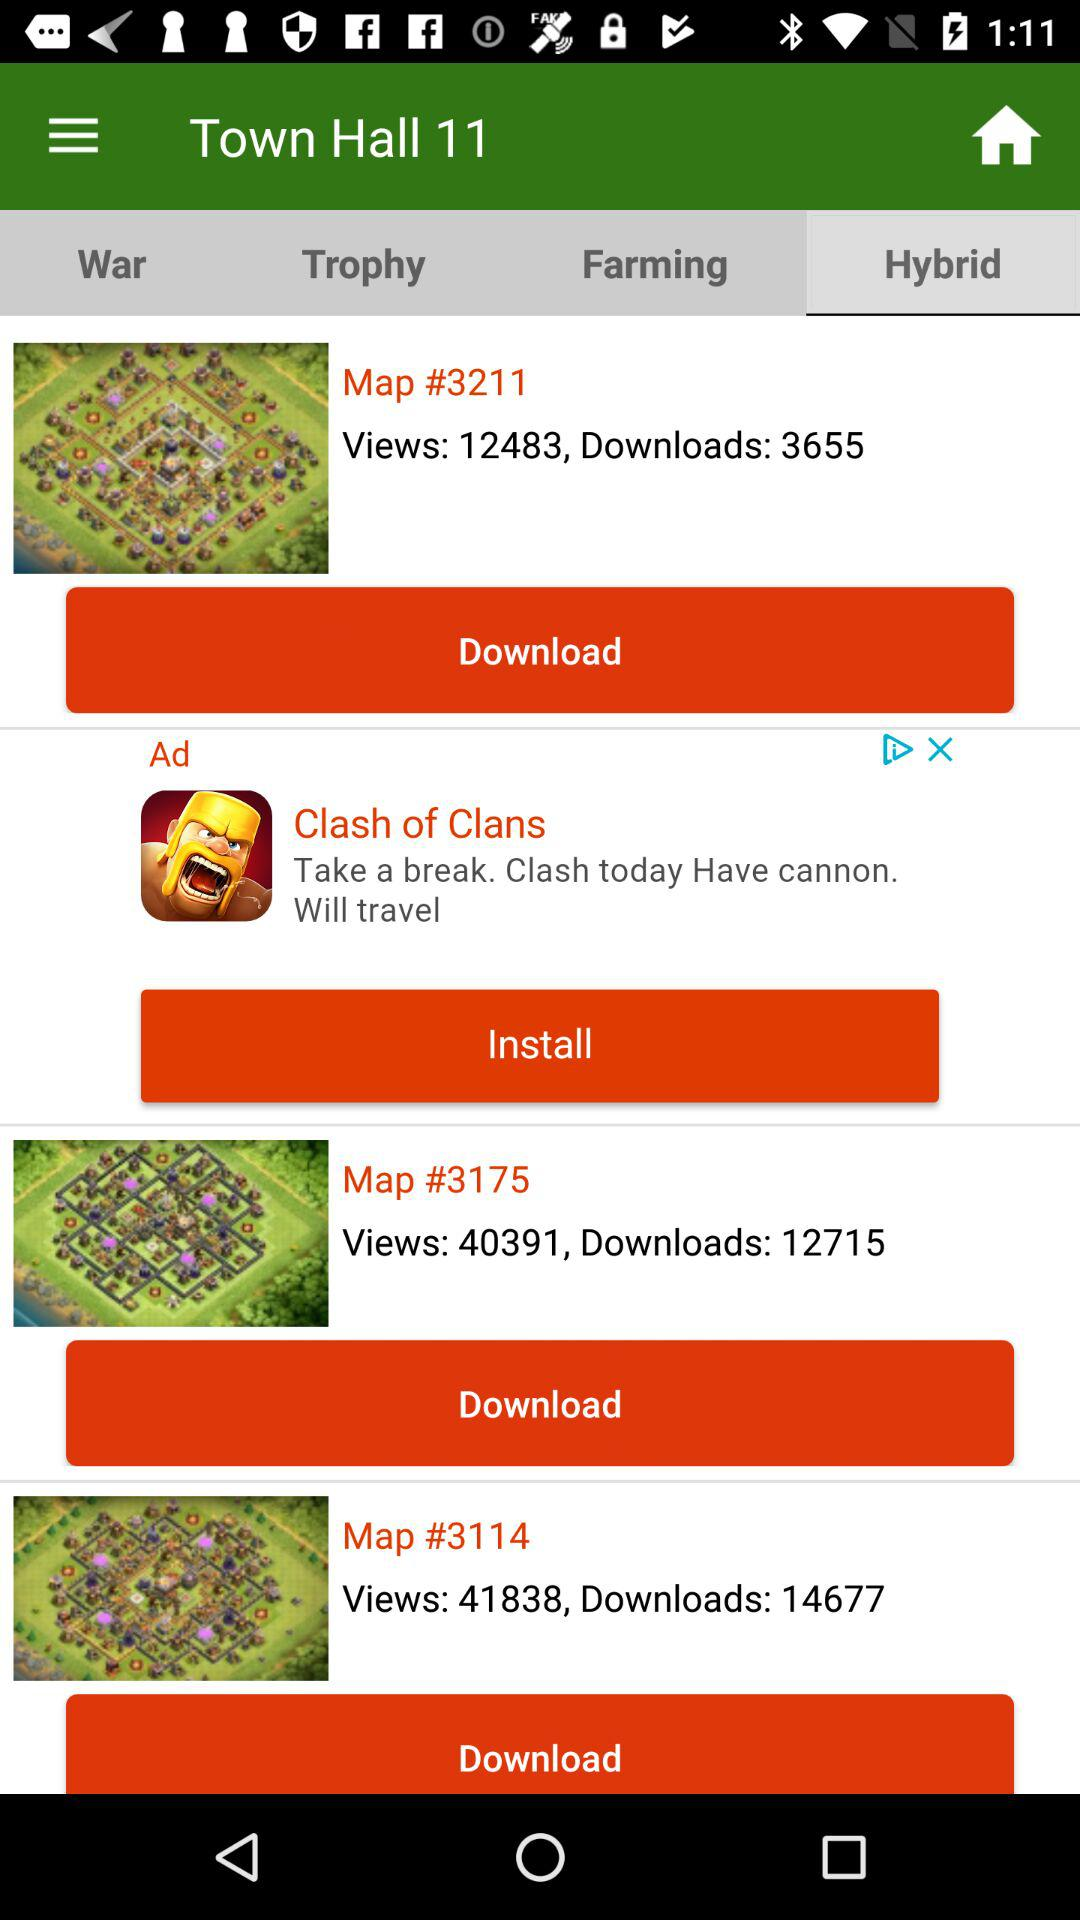How many views are there on "Map #3175"? There are 40,971 views. 